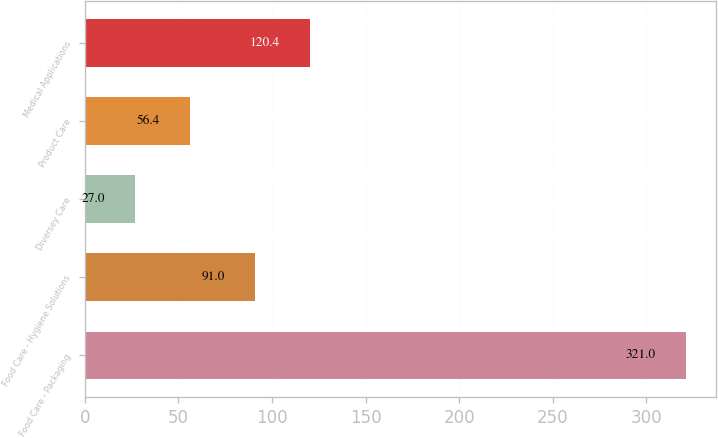Convert chart. <chart><loc_0><loc_0><loc_500><loc_500><bar_chart><fcel>Food Care - Packaging<fcel>Food Care - Hygiene Solutions<fcel>Diversey Care<fcel>Product Care<fcel>Medical Applications<nl><fcel>321<fcel>91<fcel>27<fcel>56.4<fcel>120.4<nl></chart> 